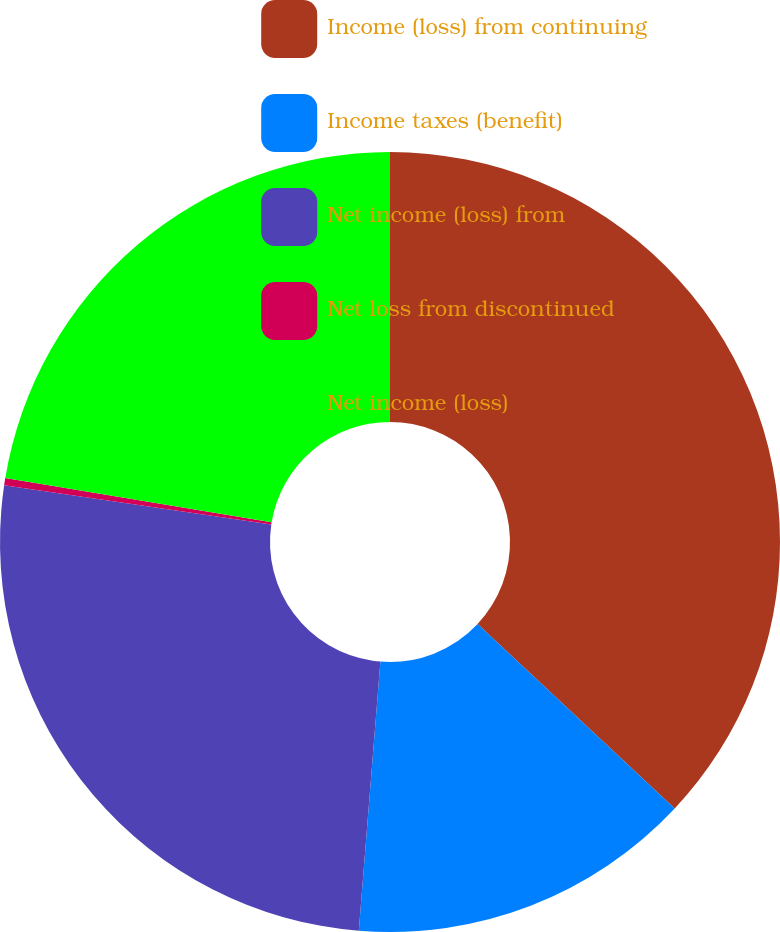Convert chart to OTSL. <chart><loc_0><loc_0><loc_500><loc_500><pie_chart><fcel>Income (loss) from continuing<fcel>Income taxes (benefit)<fcel>Net income (loss) from<fcel>Net loss from discontinued<fcel>Net income (loss)<nl><fcel>36.98%<fcel>14.3%<fcel>26.05%<fcel>0.3%<fcel>22.38%<nl></chart> 